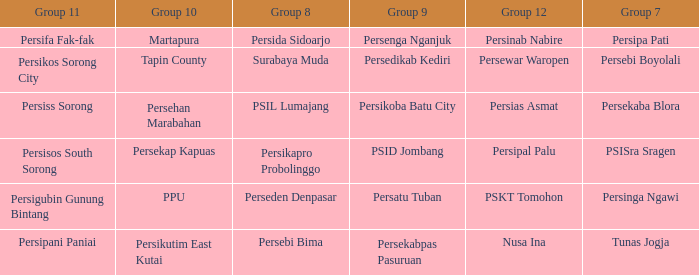Who played in group 12 when persikutim east kutai played in group 10? Nusa Ina. 